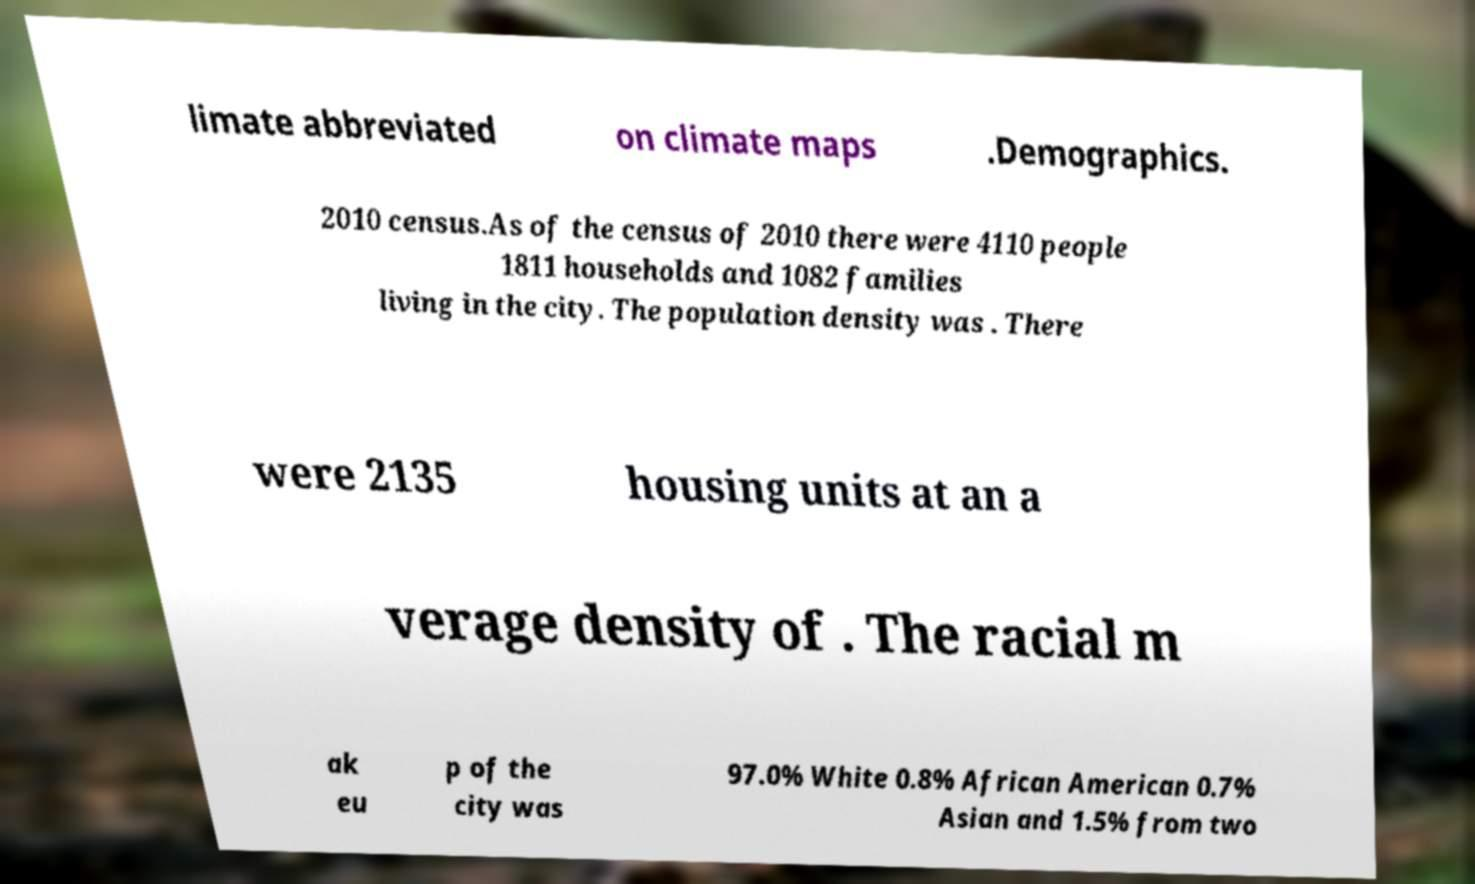Can you accurately transcribe the text from the provided image for me? limate abbreviated on climate maps .Demographics. 2010 census.As of the census of 2010 there were 4110 people 1811 households and 1082 families living in the city. The population density was . There were 2135 housing units at an a verage density of . The racial m ak eu p of the city was 97.0% White 0.8% African American 0.7% Asian and 1.5% from two 